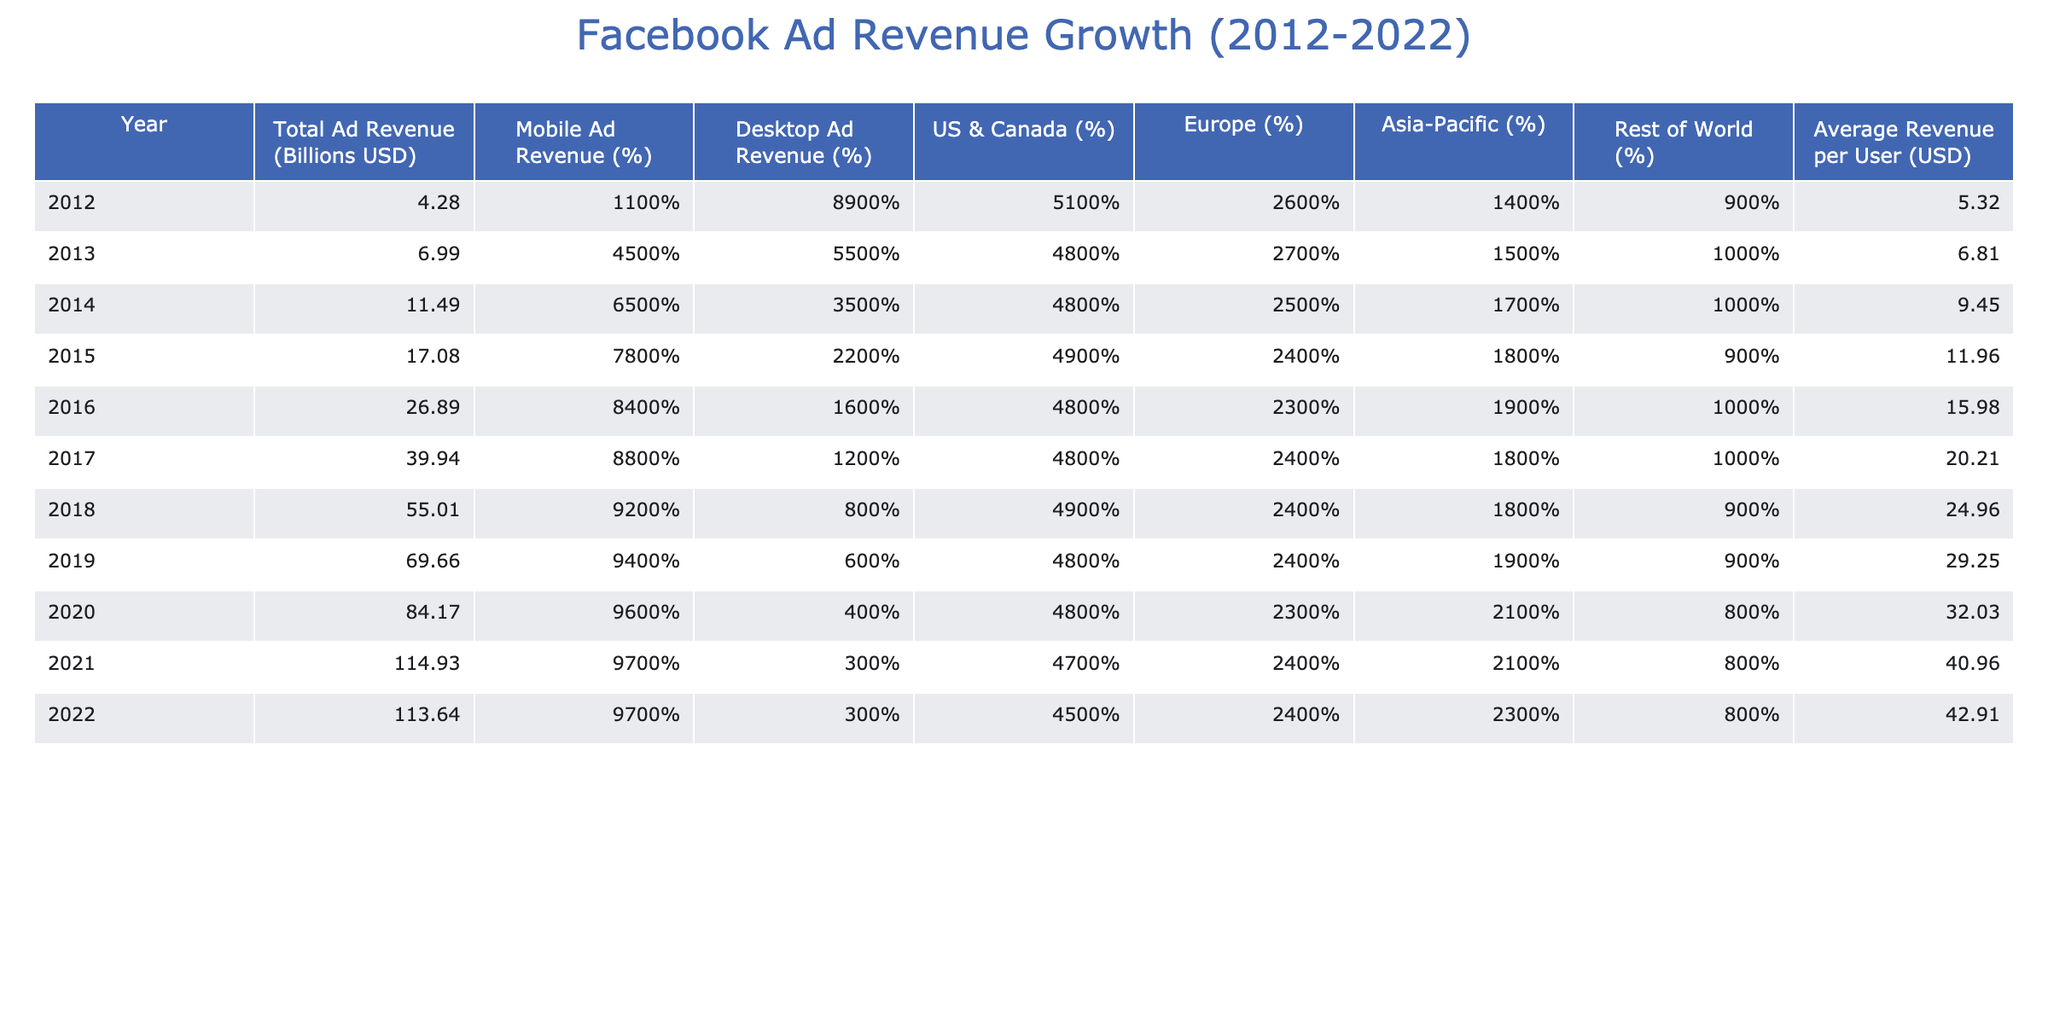What was the total ad revenue in 2019? Referring to the table, the total ad revenue listed for 2019 is 69.66 billion USD.
Answer: 69.66 billion USD What percentage of total ad revenue came from mobile ads in 2016? In 2016, the table shows that the mobile ad revenue percentage is 96%.
Answer: 96% What is the difference in total ad revenue between 2012 and 2022? The total ad revenue for 2012 is 4.28 billion USD and for 2022 it is 113.64 billion USD. The difference is 113.64 - 4.28 = 109.36 billion USD.
Answer: 109.36 billion USD Was there a decline in total ad revenue from 2021 to 2022? In 2021, the total ad revenue was 114.93 billion USD, and in 2022 it decreased to 113.64 billion USD, indicating a decline.
Answer: Yes What was the average revenue per user in 2017, and how does it compare to that in 2018? The average revenue per user in 2017 is 20.21 USD and in 2018 is 24.96 USD. The difference can be found by calculating 24.96 - 20.21 = 4.75 USD, indicating an increase from 2017 to 2018.
Answer: 4.75 USD increase In which year did mobile ad revenue first exceed 70%? Looking at the table, mobile ad revenue first exceeds 70% in 2014, where it is 65%, and exceeds 70% in 2015 at 78%.
Answer: 2015 What was the trend of average revenue per user over the entire decade? Referring to the average revenue per user across the years, we can see it increased from 5.32 USD in 2012 to 42.91 USD in 2022, indicating a positive trend over the decade.
Answer: Positive trend Was the percentage of desktop ad revenue higher than mobile ad revenue in 2012? In 2012, the desktop ad revenue percentage was 89% while mobile ad revenue was only 11%, thus it was significantly higher.
Answer: Yes What was the total ad revenue in 2020 compared to 2014? The total ad revenue in 2020 was 84.17 billion USD and in 2014 it was 11.49 billion USD. The difference is 84.17 - 11.49 = 72.68 billion USD, indicating a substantial increase.
Answer: 72.68 billion USD increase How did the percentage of ad revenue from Asia-Pacific change from 2012 to 2022? The Asia-Pacific percentage in 2012 was 14% and in 2022 it increased to 23%. The change can be calculated as 23% - 14% = 9%, indicating growth in that market.
Answer: 9% increase 